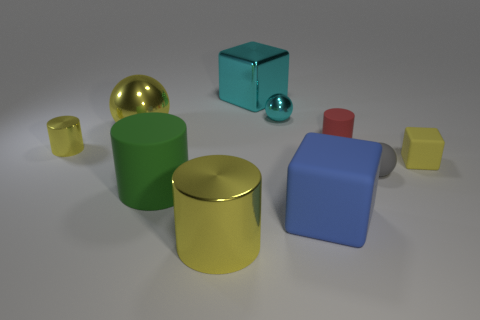Subtract all balls. How many objects are left? 7 Subtract 1 blue blocks. How many objects are left? 9 Subtract all small red things. Subtract all gray rubber objects. How many objects are left? 8 Add 7 small rubber blocks. How many small rubber blocks are left? 8 Add 8 big green objects. How many big green objects exist? 9 